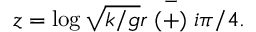<formula> <loc_0><loc_0><loc_500><loc_500>z = \log \sqrt { k / g } r \stackrel { - } { ( + ) } i \pi / 4 .</formula> 